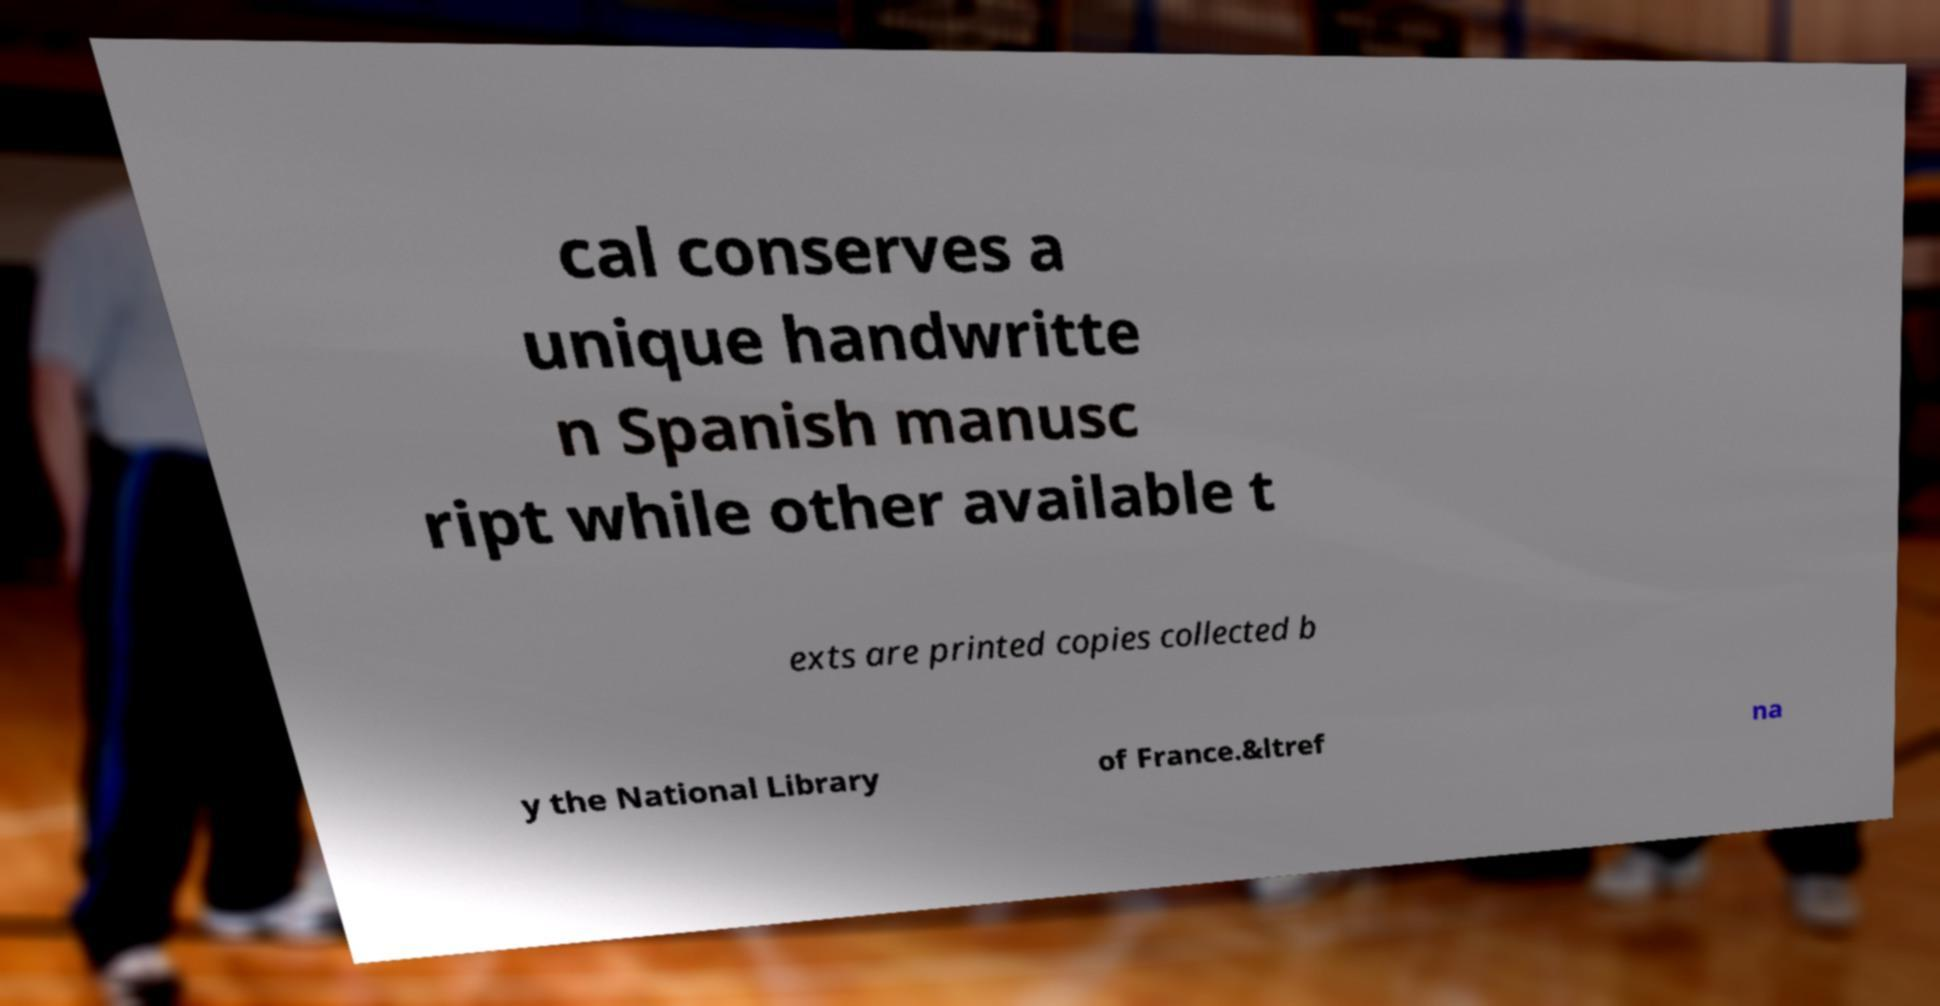I need the written content from this picture converted into text. Can you do that? cal conserves a unique handwritte n Spanish manusc ript while other available t exts are printed copies collected b y the National Library of France.&ltref na 